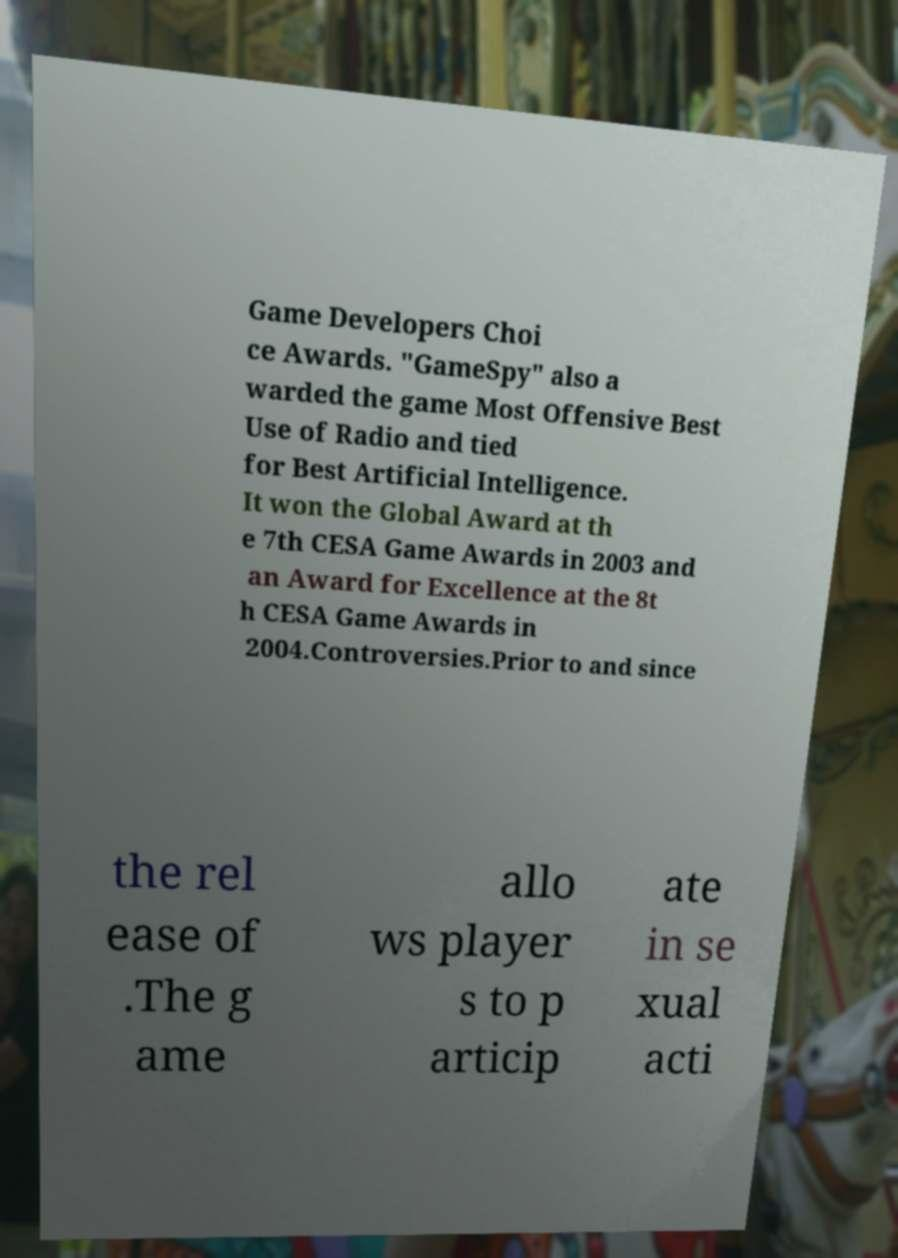There's text embedded in this image that I need extracted. Can you transcribe it verbatim? Game Developers Choi ce Awards. "GameSpy" also a warded the game Most Offensive Best Use of Radio and tied for Best Artificial Intelligence. It won the Global Award at th e 7th CESA Game Awards in 2003 and an Award for Excellence at the 8t h CESA Game Awards in 2004.Controversies.Prior to and since the rel ease of .The g ame allo ws player s to p articip ate in se xual acti 